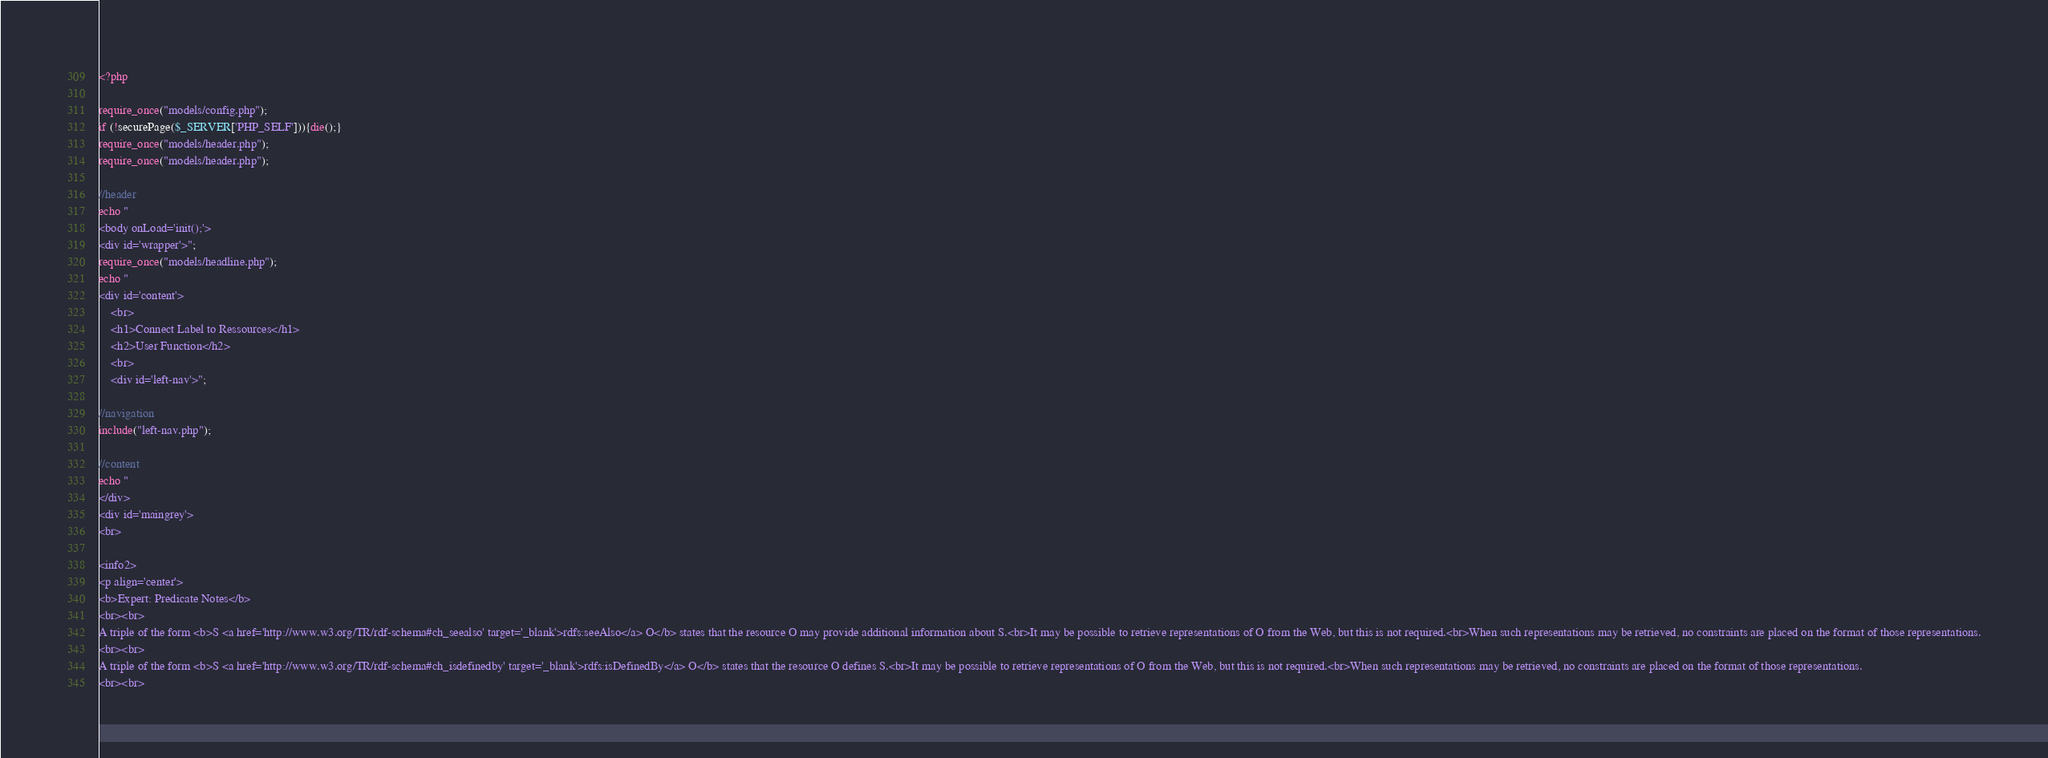<code> <loc_0><loc_0><loc_500><loc_500><_PHP_><?php

require_once("models/config.php");
if (!securePage($_SERVER['PHP_SELF'])){die();}
require_once("models/header.php");
require_once("models/header.php");

//header
echo "
<body onLoad='init();'>
<div id='wrapper'>";
require_once("models/headline.php");
echo "	
<div id='content'>
	<br>
	<h1>Connect Label to Ressources</h1>
	<h2>User Function</h2>
	<br>
	<div id='left-nav'>";
	
//navigation
include("left-nav.php");

//content
echo "
</div>
<div id='maingrey'>
<br>

<info2>
<p align='center'>
<b>Expert: Predicate Notes</b>
<br><br>
A triple of the form <b>S <a href='http://www.w3.org/TR/rdf-schema#ch_seealso' target='_blank'>rdfs:seeAlso</a> O</b> states that the resource O may provide additional information about S.<br>It may be possible to retrieve representations of O from the Web, but this is not required.<br>When such representations may be retrieved, no constraints are placed on the format of those representations.
<br><br>
A triple of the form <b>S <a href='http://www.w3.org/TR/rdf-schema#ch_isdefinedby' target='_blank'>rdfs:isDefinedBy</a> O</b> states that the resource O defines S.<br>It may be possible to retrieve representations of O from the Web, but this is not required.<br>When such representations may be retrieved, no constraints are placed on the format of those representations. 
<br><br></code> 